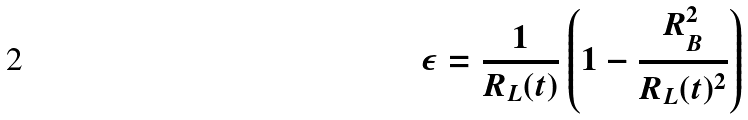<formula> <loc_0><loc_0><loc_500><loc_500>\epsilon = \frac { 1 } { R _ { L } ( t ) } \left ( 1 - \frac { R _ { B } ^ { 2 } } { R _ { L } ( t ) ^ { 2 } } \right )</formula> 